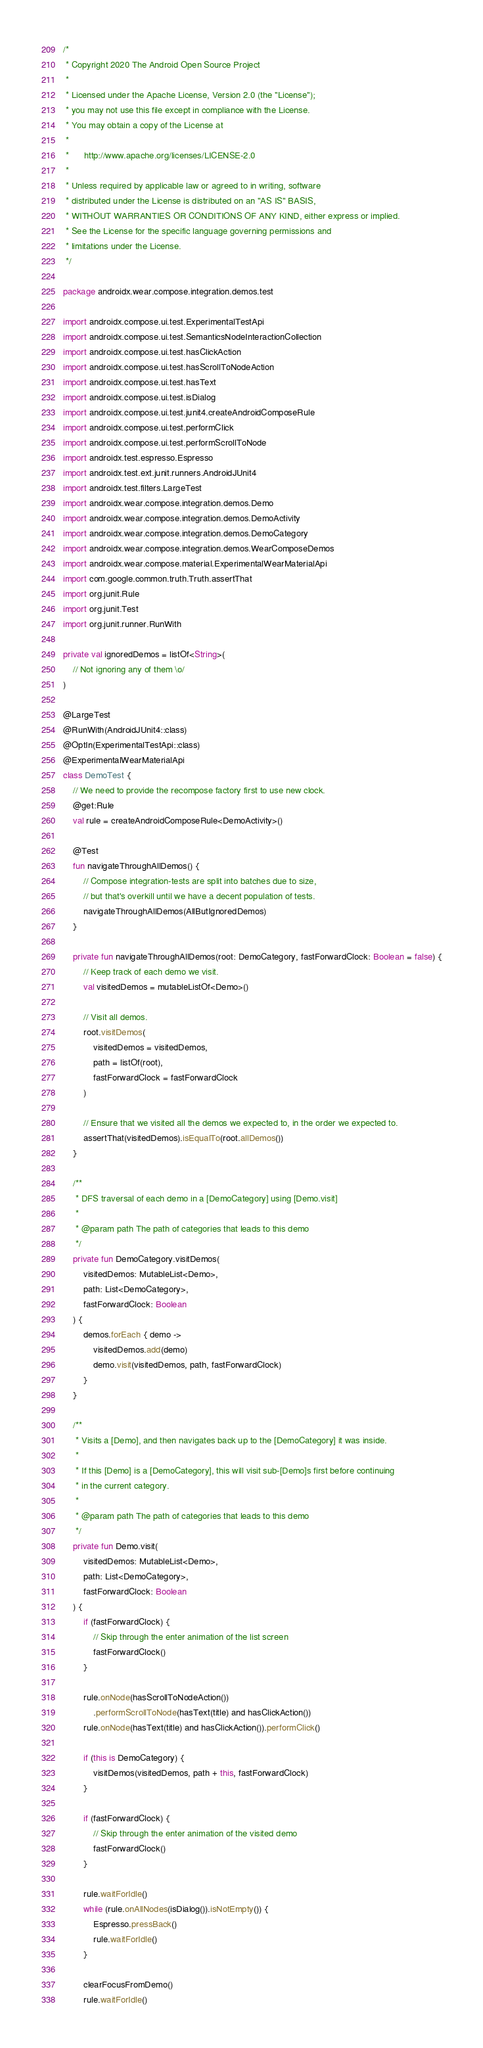<code> <loc_0><loc_0><loc_500><loc_500><_Kotlin_>/*
 * Copyright 2020 The Android Open Source Project
 *
 * Licensed under the Apache License, Version 2.0 (the "License");
 * you may not use this file except in compliance with the License.
 * You may obtain a copy of the License at
 *
 *      http://www.apache.org/licenses/LICENSE-2.0
 *
 * Unless required by applicable law or agreed to in writing, software
 * distributed under the License is distributed on an "AS IS" BASIS,
 * WITHOUT WARRANTIES OR CONDITIONS OF ANY KIND, either express or implied.
 * See the License for the specific language governing permissions and
 * limitations under the License.
 */

package androidx.wear.compose.integration.demos.test

import androidx.compose.ui.test.ExperimentalTestApi
import androidx.compose.ui.test.SemanticsNodeInteractionCollection
import androidx.compose.ui.test.hasClickAction
import androidx.compose.ui.test.hasScrollToNodeAction
import androidx.compose.ui.test.hasText
import androidx.compose.ui.test.isDialog
import androidx.compose.ui.test.junit4.createAndroidComposeRule
import androidx.compose.ui.test.performClick
import androidx.compose.ui.test.performScrollToNode
import androidx.test.espresso.Espresso
import androidx.test.ext.junit.runners.AndroidJUnit4
import androidx.test.filters.LargeTest
import androidx.wear.compose.integration.demos.Demo
import androidx.wear.compose.integration.demos.DemoActivity
import androidx.wear.compose.integration.demos.DemoCategory
import androidx.wear.compose.integration.demos.WearComposeDemos
import androidx.wear.compose.material.ExperimentalWearMaterialApi
import com.google.common.truth.Truth.assertThat
import org.junit.Rule
import org.junit.Test
import org.junit.runner.RunWith

private val ignoredDemos = listOf<String>(
    // Not ignoring any of them \o/
)

@LargeTest
@RunWith(AndroidJUnit4::class)
@OptIn(ExperimentalTestApi::class)
@ExperimentalWearMaterialApi
class DemoTest {
    // We need to provide the recompose factory first to use new clock.
    @get:Rule
    val rule = createAndroidComposeRule<DemoActivity>()

    @Test
    fun navigateThroughAllDemos() {
        // Compose integration-tests are split into batches due to size,
        // but that's overkill until we have a decent population of tests.
        navigateThroughAllDemos(AllButIgnoredDemos)
    }

    private fun navigateThroughAllDemos(root: DemoCategory, fastForwardClock: Boolean = false) {
        // Keep track of each demo we visit.
        val visitedDemos = mutableListOf<Demo>()

        // Visit all demos.
        root.visitDemos(
            visitedDemos = visitedDemos,
            path = listOf(root),
            fastForwardClock = fastForwardClock
        )

        // Ensure that we visited all the demos we expected to, in the order we expected to.
        assertThat(visitedDemos).isEqualTo(root.allDemos())
    }

    /**
     * DFS traversal of each demo in a [DemoCategory] using [Demo.visit]
     *
     * @param path The path of categories that leads to this demo
     */
    private fun DemoCategory.visitDemos(
        visitedDemos: MutableList<Demo>,
        path: List<DemoCategory>,
        fastForwardClock: Boolean
    ) {
        demos.forEach { demo ->
            visitedDemos.add(demo)
            demo.visit(visitedDemos, path, fastForwardClock)
        }
    }

    /**
     * Visits a [Demo], and then navigates back up to the [DemoCategory] it was inside.
     *
     * If this [Demo] is a [DemoCategory], this will visit sub-[Demo]s first before continuing
     * in the current category.
     *
     * @param path The path of categories that leads to this demo
     */
    private fun Demo.visit(
        visitedDemos: MutableList<Demo>,
        path: List<DemoCategory>,
        fastForwardClock: Boolean
    ) {
        if (fastForwardClock) {
            // Skip through the enter animation of the list screen
            fastForwardClock()
        }

        rule.onNode(hasScrollToNodeAction())
            .performScrollToNode(hasText(title) and hasClickAction())
        rule.onNode(hasText(title) and hasClickAction()).performClick()

        if (this is DemoCategory) {
            visitDemos(visitedDemos, path + this, fastForwardClock)
        }

        if (fastForwardClock) {
            // Skip through the enter animation of the visited demo
            fastForwardClock()
        }

        rule.waitForIdle()
        while (rule.onAllNodes(isDialog()).isNotEmpty()) {
            Espresso.pressBack()
            rule.waitForIdle()
        }

        clearFocusFromDemo()
        rule.waitForIdle()
</code> 